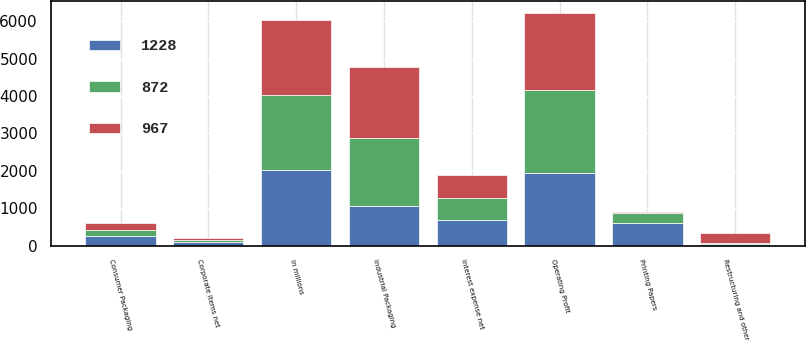Convert chart to OTSL. <chart><loc_0><loc_0><loc_500><loc_500><stacked_bar_chart><ecel><fcel>In millions<fcel>Industrial Packaging<fcel>Printing Papers<fcel>Consumer Packaging<fcel>Operating Profit<fcel>Interest expense net<fcel>Corporate items net<fcel>Restructuring and other<nl><fcel>967<fcel>2014<fcel>1896<fcel>16<fcel>178<fcel>2058<fcel>601<fcel>51<fcel>282<nl><fcel>872<fcel>2013<fcel>1801<fcel>271<fcel>161<fcel>2233<fcel>612<fcel>61<fcel>10<nl><fcel>1228<fcel>2012<fcel>1066<fcel>599<fcel>268<fcel>1933<fcel>671<fcel>87<fcel>51<nl></chart> 